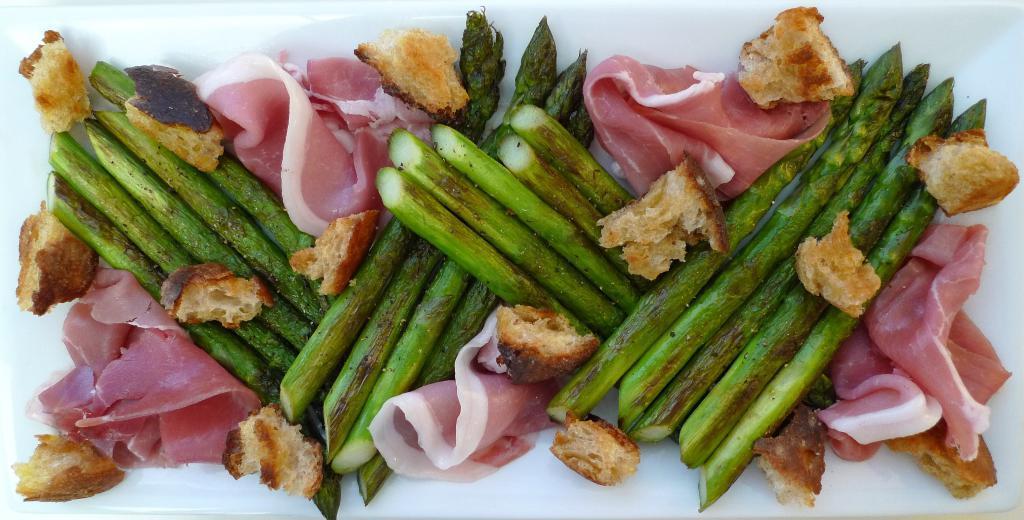Can you describe this image briefly? In this picture there is a tray in the center of the image, which contains food items in it. 